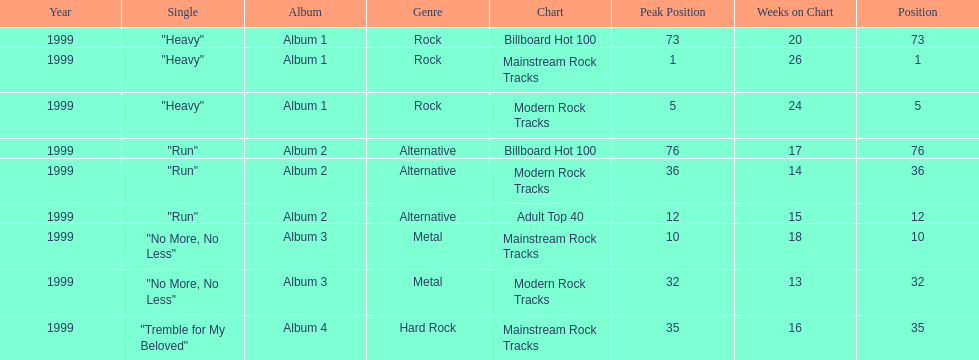Which of the singles from "dosage" had the highest billboard hot 100 rating? "Heavy". 